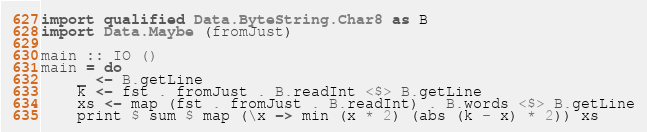Convert code to text. <code><loc_0><loc_0><loc_500><loc_500><_Haskell_>import qualified Data.ByteString.Char8 as B
import Data.Maybe (fromJust)

main :: IO ()
main = do
    _ <- B.getLine
    k <- fst . fromJust . B.readInt <$> B.getLine
    xs <- map (fst . fromJust . B.readInt) . B.words <$> B.getLine
    print $ sum $ map (\x -> min (x * 2) (abs (k - x) * 2)) xs
</code> 